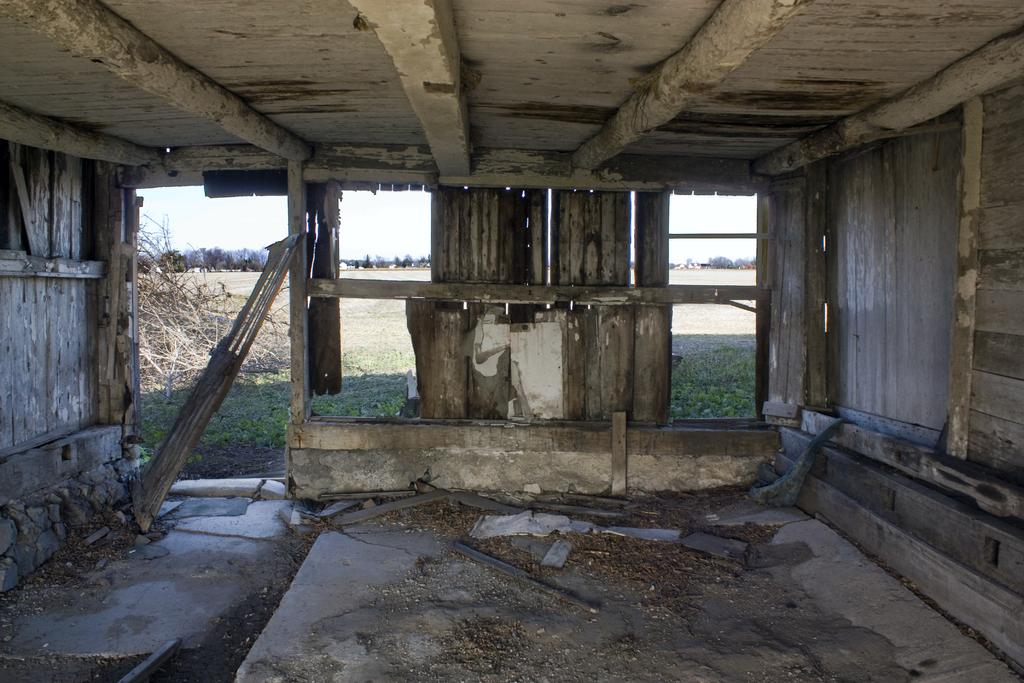What type of structure is present in the image? There is a wooden shed in the image. What can be seen outside the shed? Tree stocks are visible outside the shed. What is visible in the background of the image? There are many trees in the background of the image. How would you describe the color of the sky in the image? The sky is white in the image. What time of day is it in the image, considering the presence of a zebra? There is no zebra present in the image, so we cannot determine the time of day based on that information. 